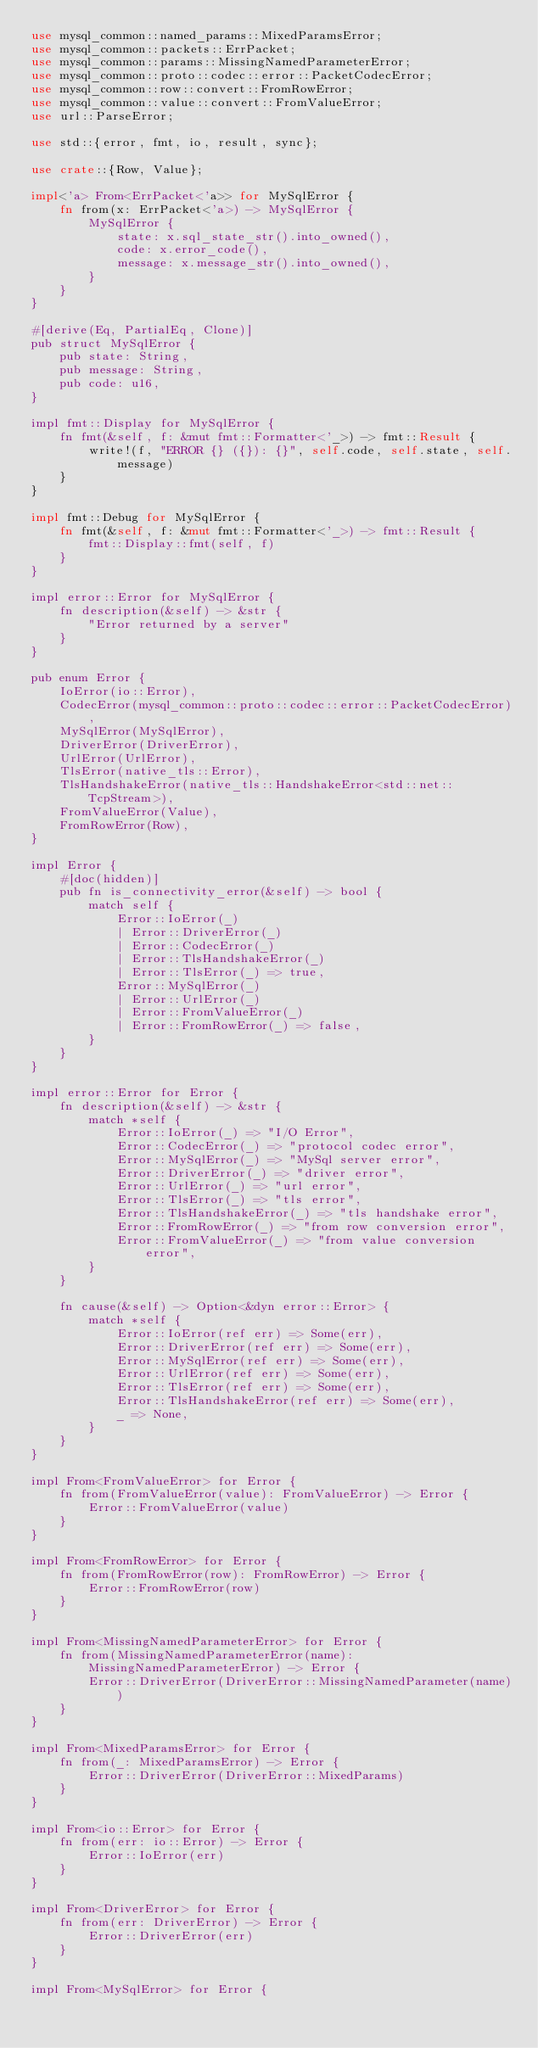Convert code to text. <code><loc_0><loc_0><loc_500><loc_500><_Rust_>use mysql_common::named_params::MixedParamsError;
use mysql_common::packets::ErrPacket;
use mysql_common::params::MissingNamedParameterError;
use mysql_common::proto::codec::error::PacketCodecError;
use mysql_common::row::convert::FromRowError;
use mysql_common::value::convert::FromValueError;
use url::ParseError;

use std::{error, fmt, io, result, sync};

use crate::{Row, Value};

impl<'a> From<ErrPacket<'a>> for MySqlError {
    fn from(x: ErrPacket<'a>) -> MySqlError {
        MySqlError {
            state: x.sql_state_str().into_owned(),
            code: x.error_code(),
            message: x.message_str().into_owned(),
        }
    }
}

#[derive(Eq, PartialEq, Clone)]
pub struct MySqlError {
    pub state: String,
    pub message: String,
    pub code: u16,
}

impl fmt::Display for MySqlError {
    fn fmt(&self, f: &mut fmt::Formatter<'_>) -> fmt::Result {
        write!(f, "ERROR {} ({}): {}", self.code, self.state, self.message)
    }
}

impl fmt::Debug for MySqlError {
    fn fmt(&self, f: &mut fmt::Formatter<'_>) -> fmt::Result {
        fmt::Display::fmt(self, f)
    }
}

impl error::Error for MySqlError {
    fn description(&self) -> &str {
        "Error returned by a server"
    }
}

pub enum Error {
    IoError(io::Error),
    CodecError(mysql_common::proto::codec::error::PacketCodecError),
    MySqlError(MySqlError),
    DriverError(DriverError),
    UrlError(UrlError),
    TlsError(native_tls::Error),
    TlsHandshakeError(native_tls::HandshakeError<std::net::TcpStream>),
    FromValueError(Value),
    FromRowError(Row),
}

impl Error {
    #[doc(hidden)]
    pub fn is_connectivity_error(&self) -> bool {
        match self {
            Error::IoError(_)
            | Error::DriverError(_)
            | Error::CodecError(_)
            | Error::TlsHandshakeError(_)
            | Error::TlsError(_) => true,
            Error::MySqlError(_)
            | Error::UrlError(_)
            | Error::FromValueError(_)
            | Error::FromRowError(_) => false,
        }
    }
}

impl error::Error for Error {
    fn description(&self) -> &str {
        match *self {
            Error::IoError(_) => "I/O Error",
            Error::CodecError(_) => "protocol codec error",
            Error::MySqlError(_) => "MySql server error",
            Error::DriverError(_) => "driver error",
            Error::UrlError(_) => "url error",
            Error::TlsError(_) => "tls error",
            Error::TlsHandshakeError(_) => "tls handshake error",
            Error::FromRowError(_) => "from row conversion error",
            Error::FromValueError(_) => "from value conversion error",
        }
    }

    fn cause(&self) -> Option<&dyn error::Error> {
        match *self {
            Error::IoError(ref err) => Some(err),
            Error::DriverError(ref err) => Some(err),
            Error::MySqlError(ref err) => Some(err),
            Error::UrlError(ref err) => Some(err),
            Error::TlsError(ref err) => Some(err),
            Error::TlsHandshakeError(ref err) => Some(err),
            _ => None,
        }
    }
}

impl From<FromValueError> for Error {
    fn from(FromValueError(value): FromValueError) -> Error {
        Error::FromValueError(value)
    }
}

impl From<FromRowError> for Error {
    fn from(FromRowError(row): FromRowError) -> Error {
        Error::FromRowError(row)
    }
}

impl From<MissingNamedParameterError> for Error {
    fn from(MissingNamedParameterError(name): MissingNamedParameterError) -> Error {
        Error::DriverError(DriverError::MissingNamedParameter(name))
    }
}

impl From<MixedParamsError> for Error {
    fn from(_: MixedParamsError) -> Error {
        Error::DriverError(DriverError::MixedParams)
    }
}

impl From<io::Error> for Error {
    fn from(err: io::Error) -> Error {
        Error::IoError(err)
    }
}

impl From<DriverError> for Error {
    fn from(err: DriverError) -> Error {
        Error::DriverError(err)
    }
}

impl From<MySqlError> for Error {</code> 